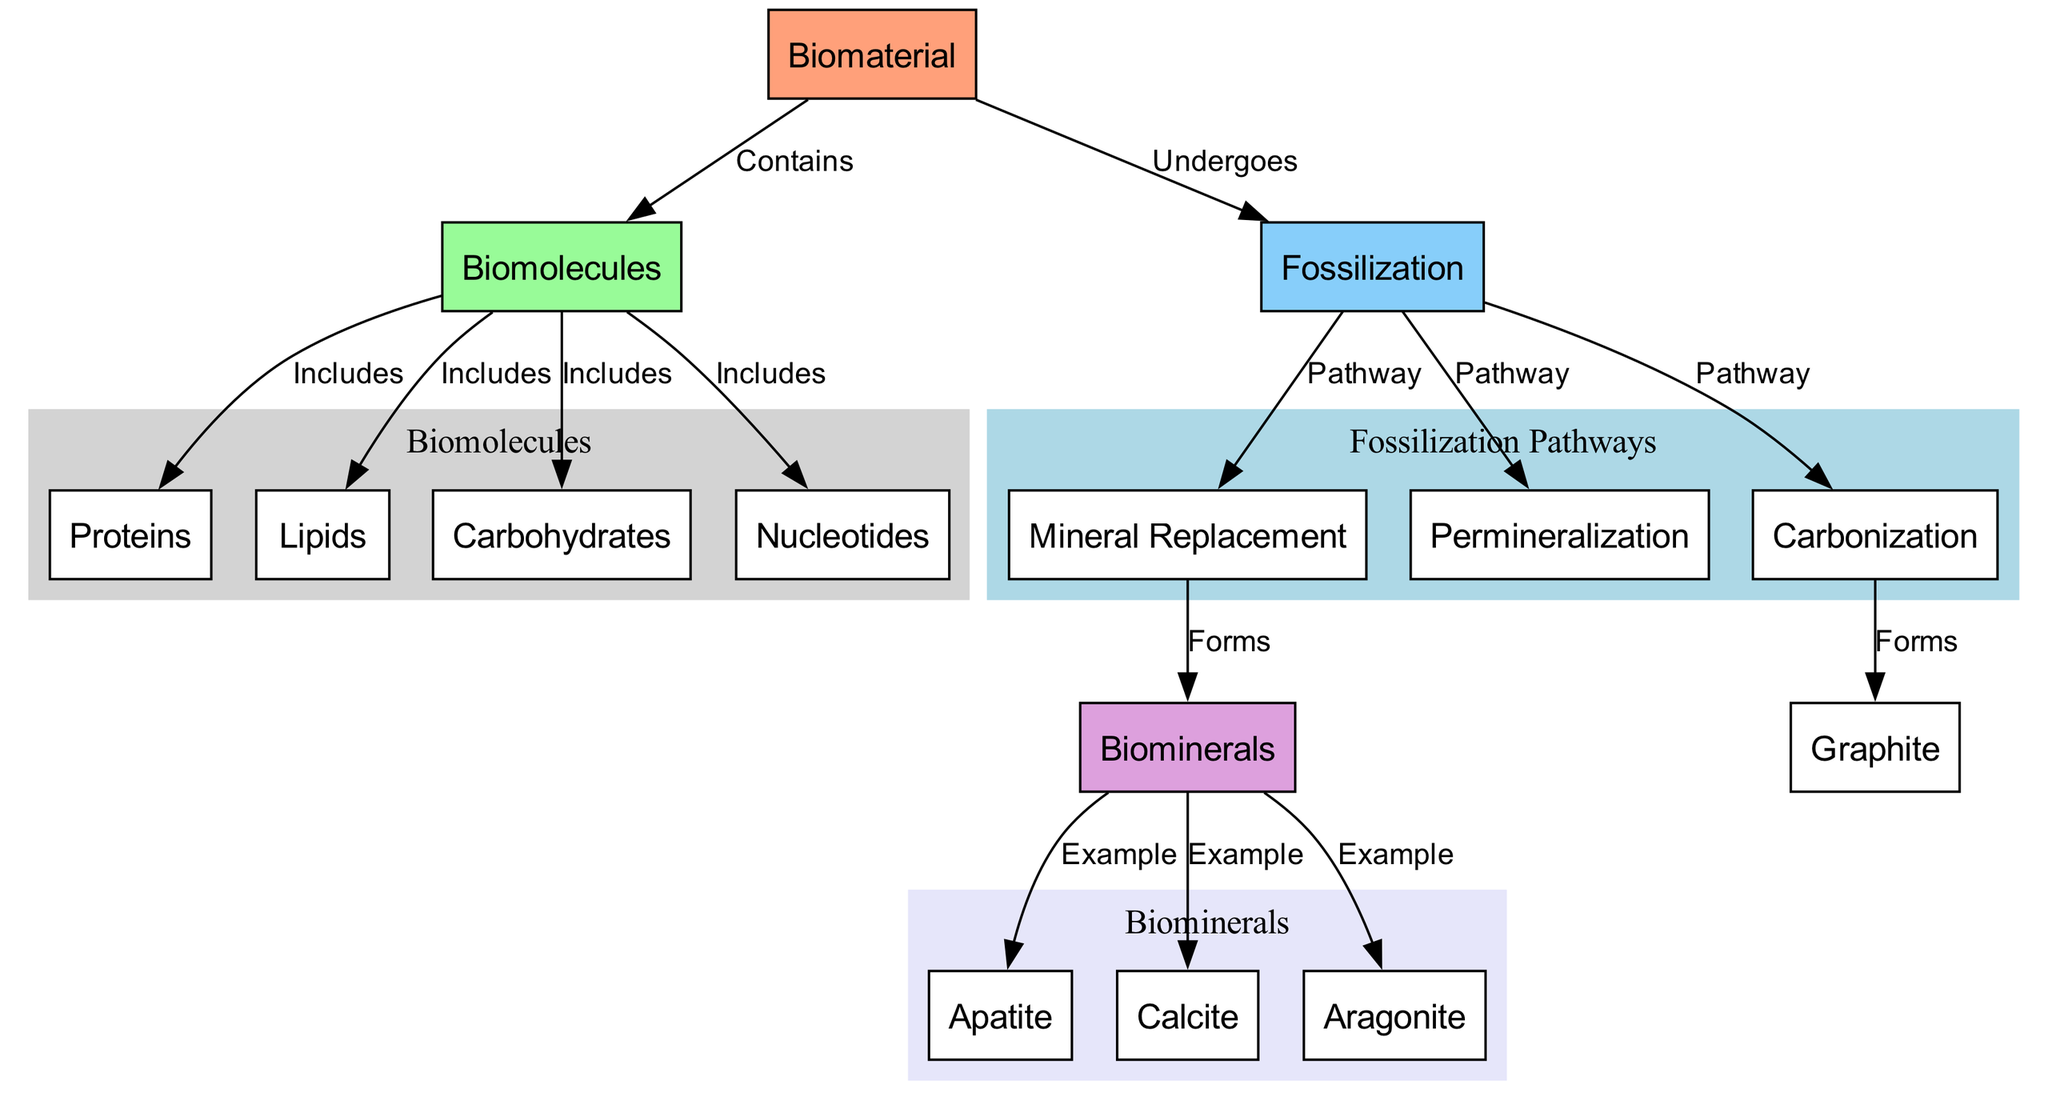What is the primary biomaterial mentioned in the diagram? The diagram indicates "Biomaterial" as the root node, which represents the main focus of the pathways.
Answer: Biomaterial How many biomolecule types are included under biomolecules? The diagram shows four specific types of biomolecules: Proteins, Lipids, Carbohydrates, and Nucleotides listed under the "Biomolecules" node.
Answer: Four What is one example of a biomineral formed through mineral replacement? From the connections stemming from the Biominerals node, the diagram lists Apatite, Calcite, and Aragonite as examples of biominerals formed through mineral replacement.
Answer: Apatite What type of fossilization pathway leads to the formation of graphite? The diagram indicates "Carbonization" as the pathway leading to the formation of Graphite, as shown by the direct edge connecting these two nodes.
Answer: Carbonization Which biomolecules contribute to the biomaterial? The "Biomolecules" node is connected to "Proteins," "Lipids," "Carbohydrates," and "Nucleotides," indicating these are components of the biomaterial.
Answer: Proteins, Lipids, Carbohydrates, Nucleotides What forms through permineralization during fossilization? The diagram clearly outlines that "Permineralization" is one of the pathways of fossilization but does not specify the exact forms derived from it; however, it implies that biominerals like Apatite, Calcite, and Aragonite can relate to mineral replacement instead. Specifically, by referencing the relationships in the nodes, it can imply a similar resultant.
Answer: Biominerals How many pathways of fossilization are exhibited in the diagram? The diagram features three distinct pathways: Mineral Replacement, Permineralization, and Carbonization, which are evident as edges stemming from the Fossilization node.
Answer: Three What are the primary biopolymers found in the biomolecular components? The diagram includes Proteins, Lipids, Carbohydrates, and Nucleotides under the Biomolecules category, indicating these are the main biopolymers represented.
Answer: Proteins, Lipids, Carbohydrates, Nucleotides Which node is connected to the fossilization node through a pathway label? The edge connects the "Fossilization" node to "Mineral Replacement," "Permineralization," and "Carbonization," clearly indicating these are the fossilization pathways.
Answer: Mineral Replacement, Permineralization, Carbonization 